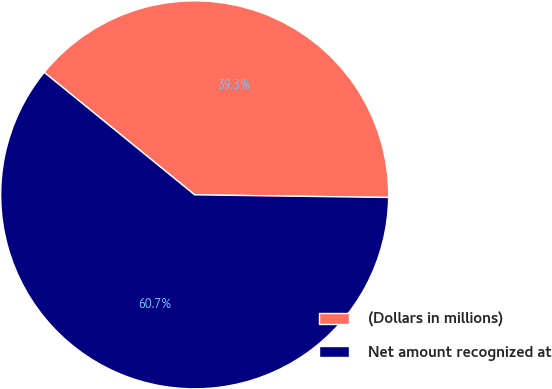Convert chart. <chart><loc_0><loc_0><loc_500><loc_500><pie_chart><fcel>(Dollars in millions)<fcel>Net amount recognized at<nl><fcel>39.34%<fcel>60.66%<nl></chart> 